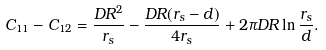Convert formula to latex. <formula><loc_0><loc_0><loc_500><loc_500>C _ { 1 1 } - C _ { 1 2 } = \frac { D R ^ { 2 } } { r _ { s } } - \frac { D R ( r _ { s } - d ) } { 4 r _ { s } } + 2 \pi D R \ln \frac { r _ { s } } { d } .</formula> 